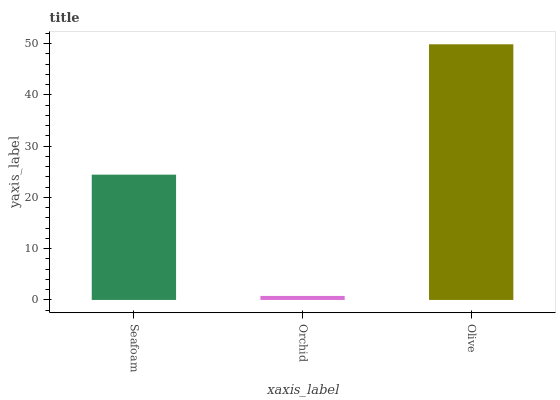Is Orchid the minimum?
Answer yes or no. Yes. Is Olive the maximum?
Answer yes or no. Yes. Is Olive the minimum?
Answer yes or no. No. Is Orchid the maximum?
Answer yes or no. No. Is Olive greater than Orchid?
Answer yes or no. Yes. Is Orchid less than Olive?
Answer yes or no. Yes. Is Orchid greater than Olive?
Answer yes or no. No. Is Olive less than Orchid?
Answer yes or no. No. Is Seafoam the high median?
Answer yes or no. Yes. Is Seafoam the low median?
Answer yes or no. Yes. Is Olive the high median?
Answer yes or no. No. Is Orchid the low median?
Answer yes or no. No. 